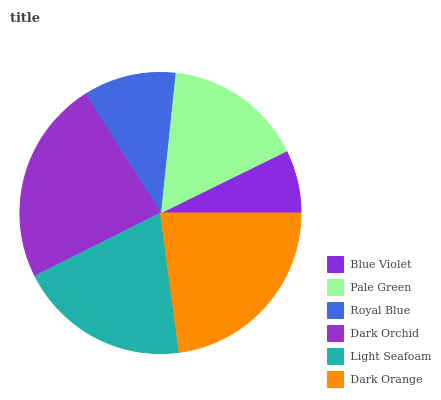Is Blue Violet the minimum?
Answer yes or no. Yes. Is Dark Orchid the maximum?
Answer yes or no. Yes. Is Pale Green the minimum?
Answer yes or no. No. Is Pale Green the maximum?
Answer yes or no. No. Is Pale Green greater than Blue Violet?
Answer yes or no. Yes. Is Blue Violet less than Pale Green?
Answer yes or no. Yes. Is Blue Violet greater than Pale Green?
Answer yes or no. No. Is Pale Green less than Blue Violet?
Answer yes or no. No. Is Light Seafoam the high median?
Answer yes or no. Yes. Is Pale Green the low median?
Answer yes or no. Yes. Is Pale Green the high median?
Answer yes or no. No. Is Light Seafoam the low median?
Answer yes or no. No. 